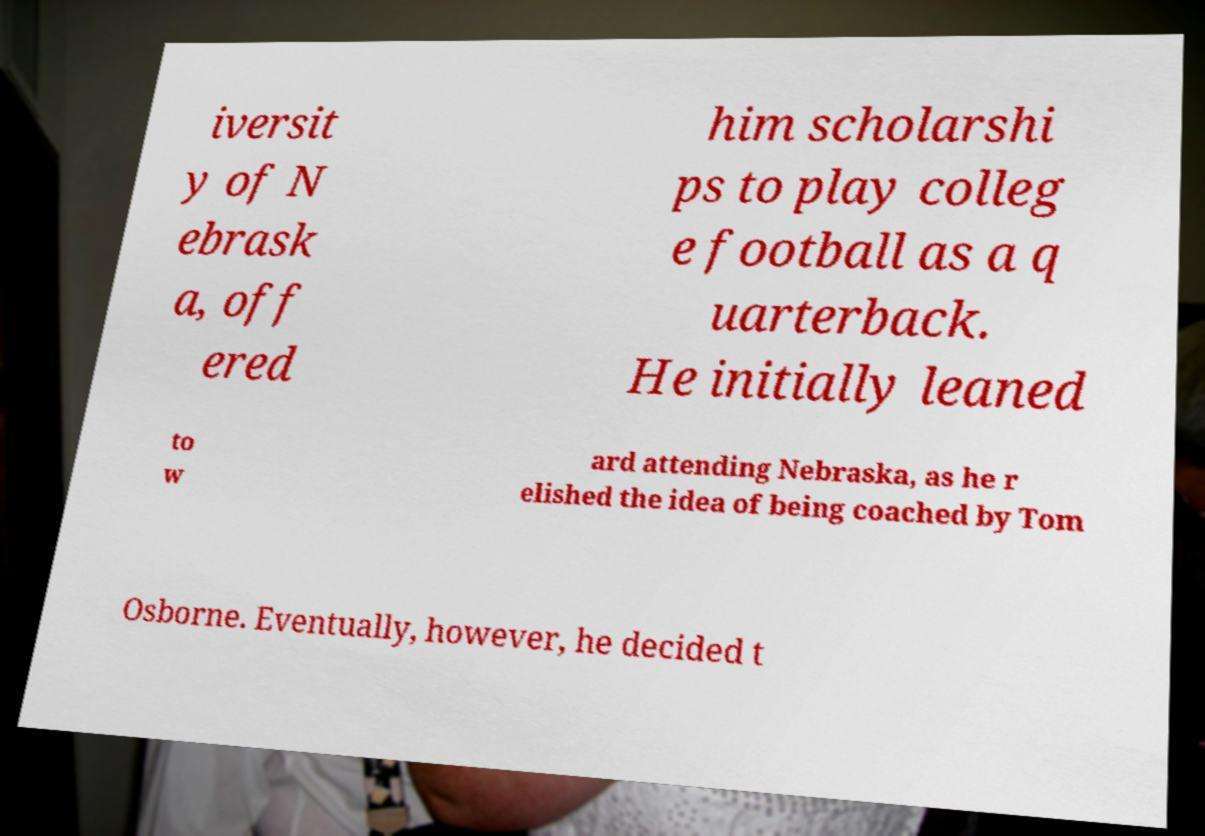Could you assist in decoding the text presented in this image and type it out clearly? iversit y of N ebrask a, off ered him scholarshi ps to play colleg e football as a q uarterback. He initially leaned to w ard attending Nebraska, as he r elished the idea of being coached by Tom Osborne. Eventually, however, he decided t 